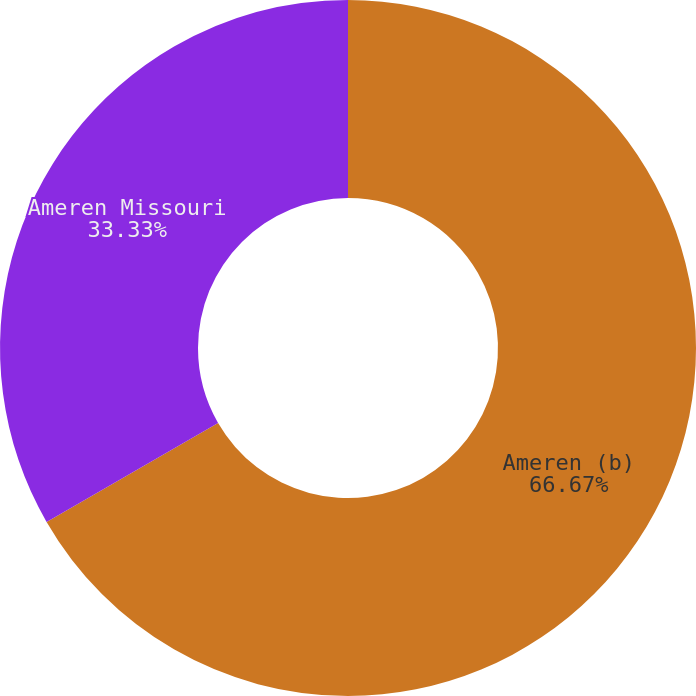Convert chart. <chart><loc_0><loc_0><loc_500><loc_500><pie_chart><fcel>Ameren (b)<fcel>Ameren Missouri<nl><fcel>66.67%<fcel>33.33%<nl></chart> 